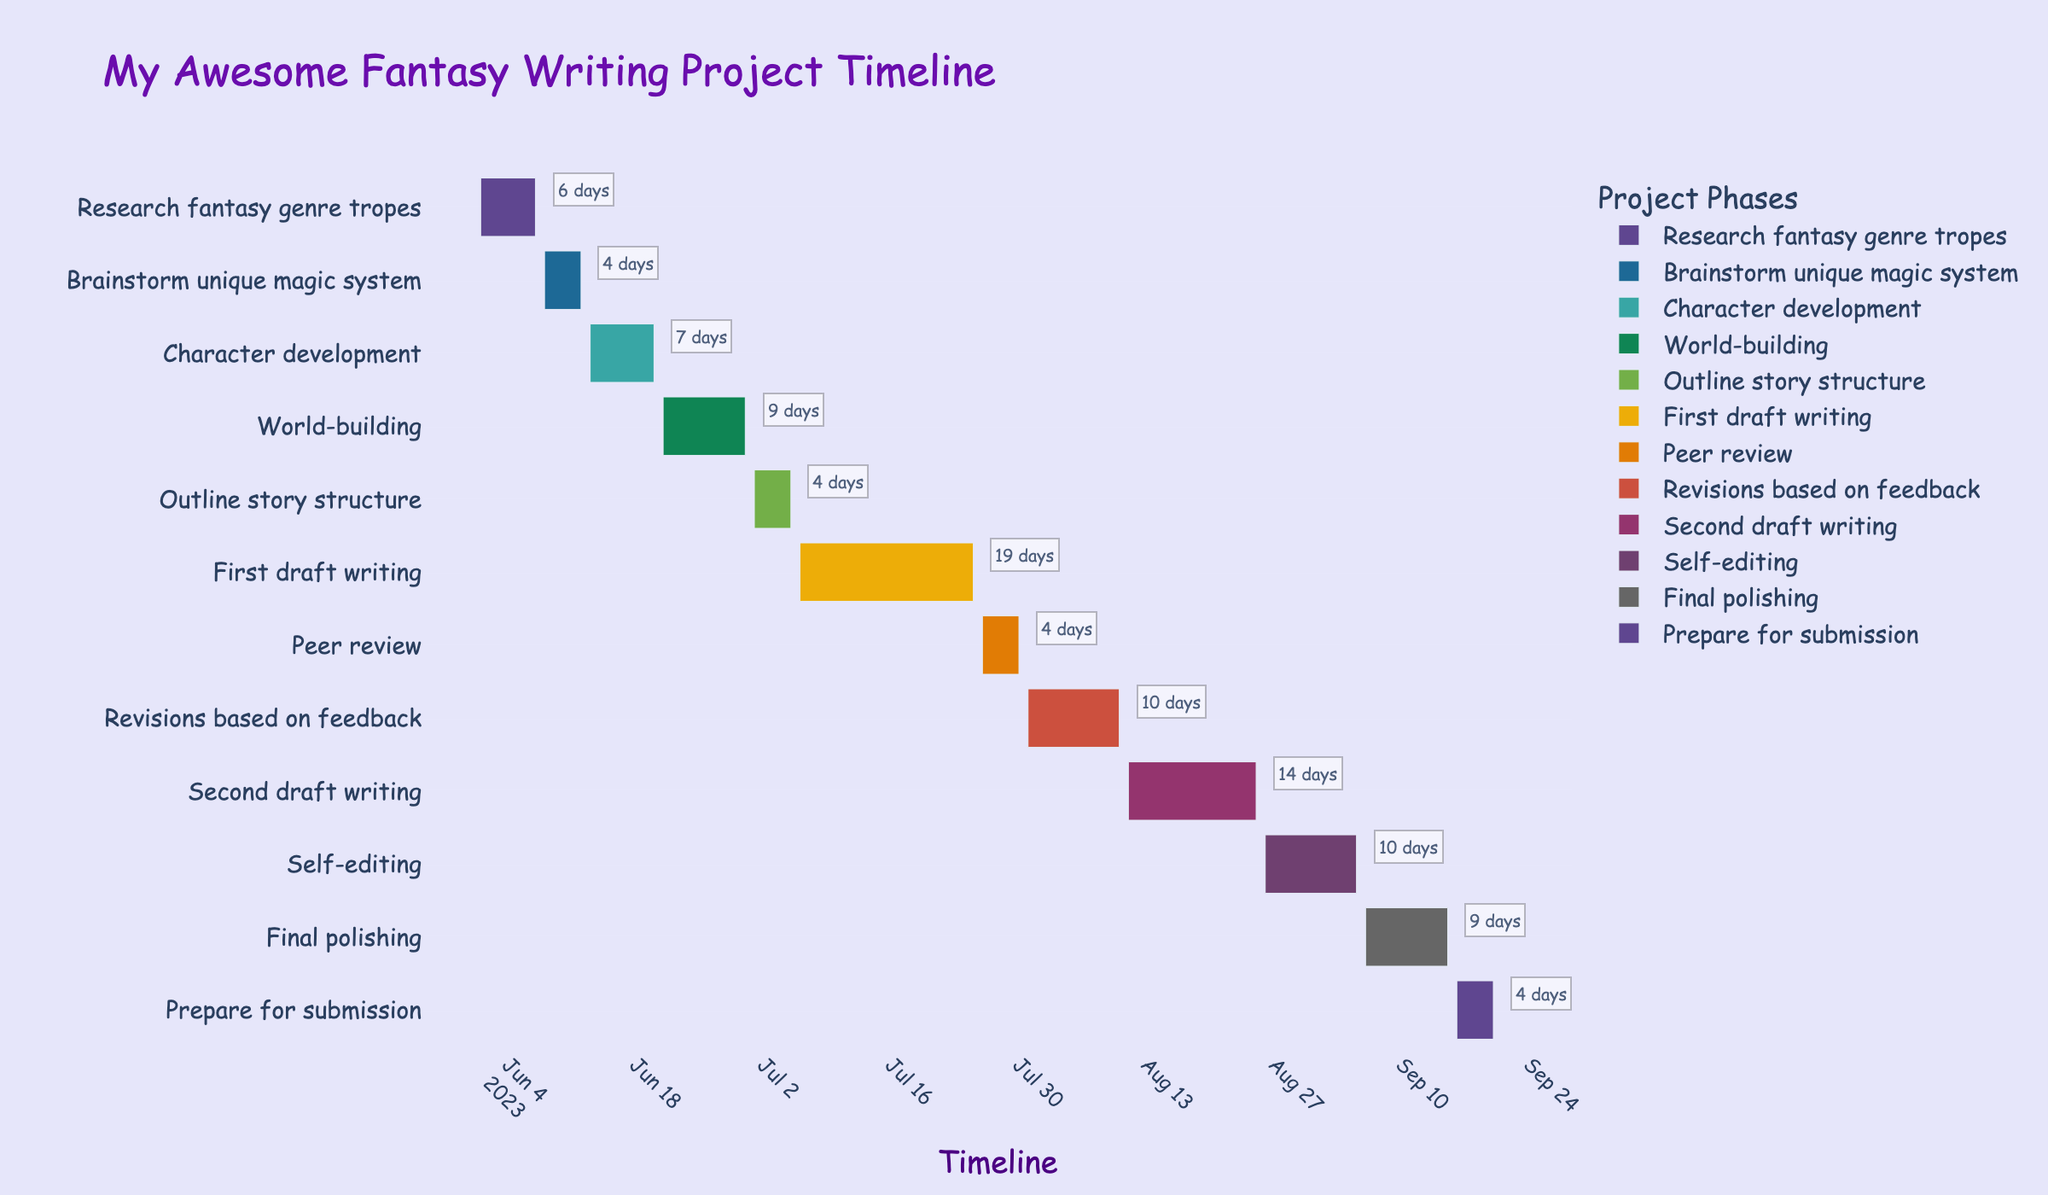What's the title of the Gantt chart? The title can be found at the top of the Gantt chart where it is usually prominently displayed. In this case, look for a big and colorful title at the top.
Answer: My Awesome Fantasy Writing Project Timeline How many days are allocated for self-editing? Identify the task "Self-editing" on the y-axis, then refer to the x-axis for the start and end dates. The task runs from 2023-08-26 to 2023-09-05.
Answer: 11 days Which task has the longest duration? Compare the durations specified next to each task. Look for the task span that has the highest number of days.
Answer: First draft writing What is the total number of days planned for drafting phases? Add the durations of "First draft writing" and "Second draft writing": 20 days (First draft) + 15 days (Second draft) = 35 days.
Answer: 35 days Does any task start immediately after another without any gap? Check the end date of one task and the start date of the next task across the Gantt chart. Specifically, see if "Research fantasy genre tropes" ends on 2023-06-07 and "Brainstorm unique magic system" starts on 2023-06-08.
Answer: Yes Which task is completed closest to the submission preparation phase? Look at the end date of the task just before "Prepare for submission," which ends right before 2023-09-16. Identify the "Final polishing" task.
Answer: Final polishing How many tasks are completed by the end of June 2023? Check the end dates for all tasks listed and count the tasks with end dates on or before 2023-06-30.
Answer: 4 tasks Between research and brainstorming phases, which is longer? Compare the durations of "Research fantasy genre tropes" (7 days) and "Brainstorm unique magic system" (5 days).
Answer: Research fantasy genre tropes Which phase has the shortest duration? Identify the task with the smallest number of days next to it.
Answer: Peer review What is the total duration of the project from start to submission preparation? Calculate the number of days from the start date of the first task (2023-06-01) to the end date of the last task before submission (2023-09-20).
Answer: 112 days 